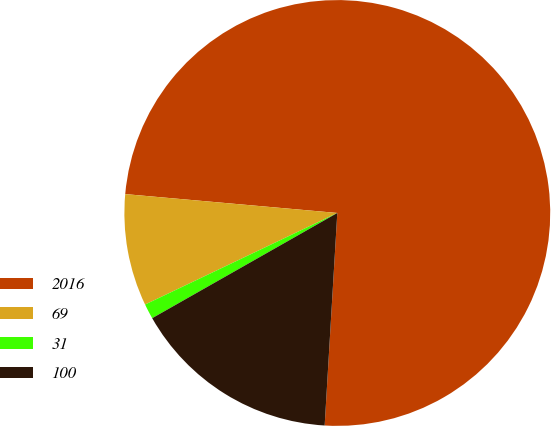<chart> <loc_0><loc_0><loc_500><loc_500><pie_chart><fcel>2016<fcel>69<fcel>31<fcel>100<nl><fcel>74.54%<fcel>8.49%<fcel>1.15%<fcel>15.83%<nl></chart> 